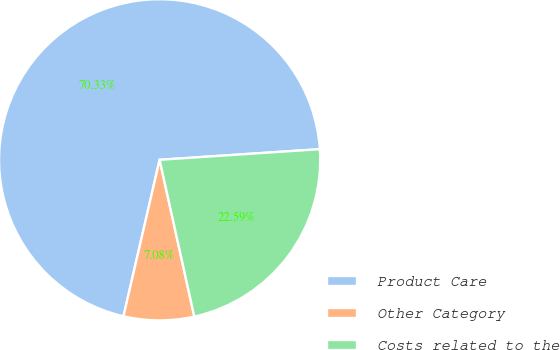Convert chart to OTSL. <chart><loc_0><loc_0><loc_500><loc_500><pie_chart><fcel>Product Care<fcel>Other Category<fcel>Costs related to the<nl><fcel>70.33%<fcel>7.08%<fcel>22.59%<nl></chart> 